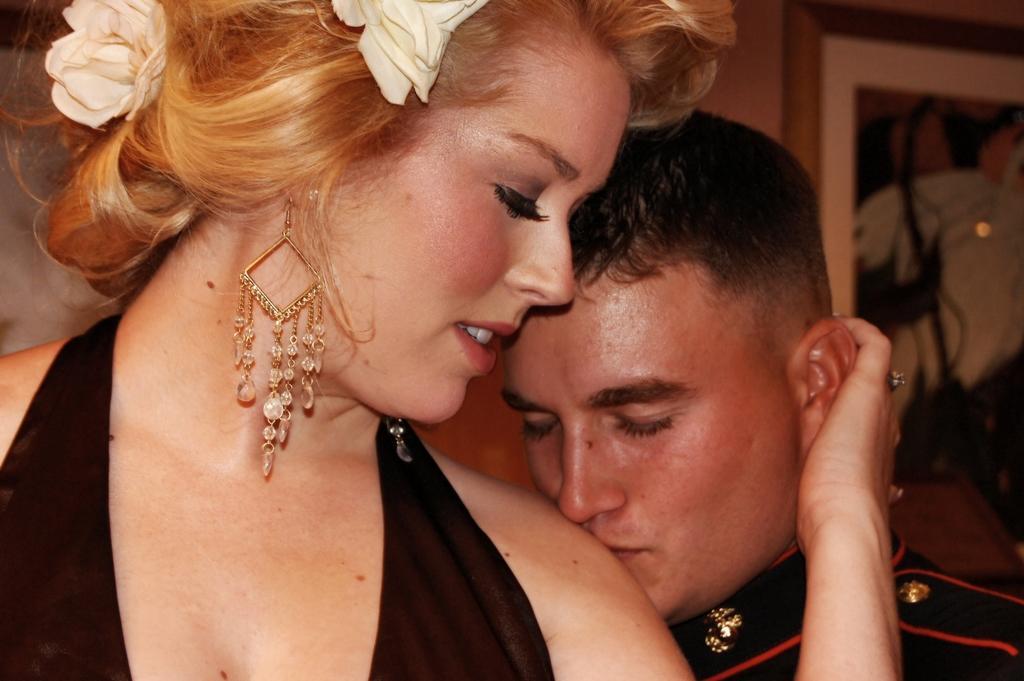Can you describe this image briefly? In this image in the foreground there is one man and one woman, and in the background there is a photo frame on the wall. 